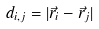Convert formula to latex. <formula><loc_0><loc_0><loc_500><loc_500>d _ { i , j } = | \vec { r } _ { i } - \vec { r } _ { j } |</formula> 